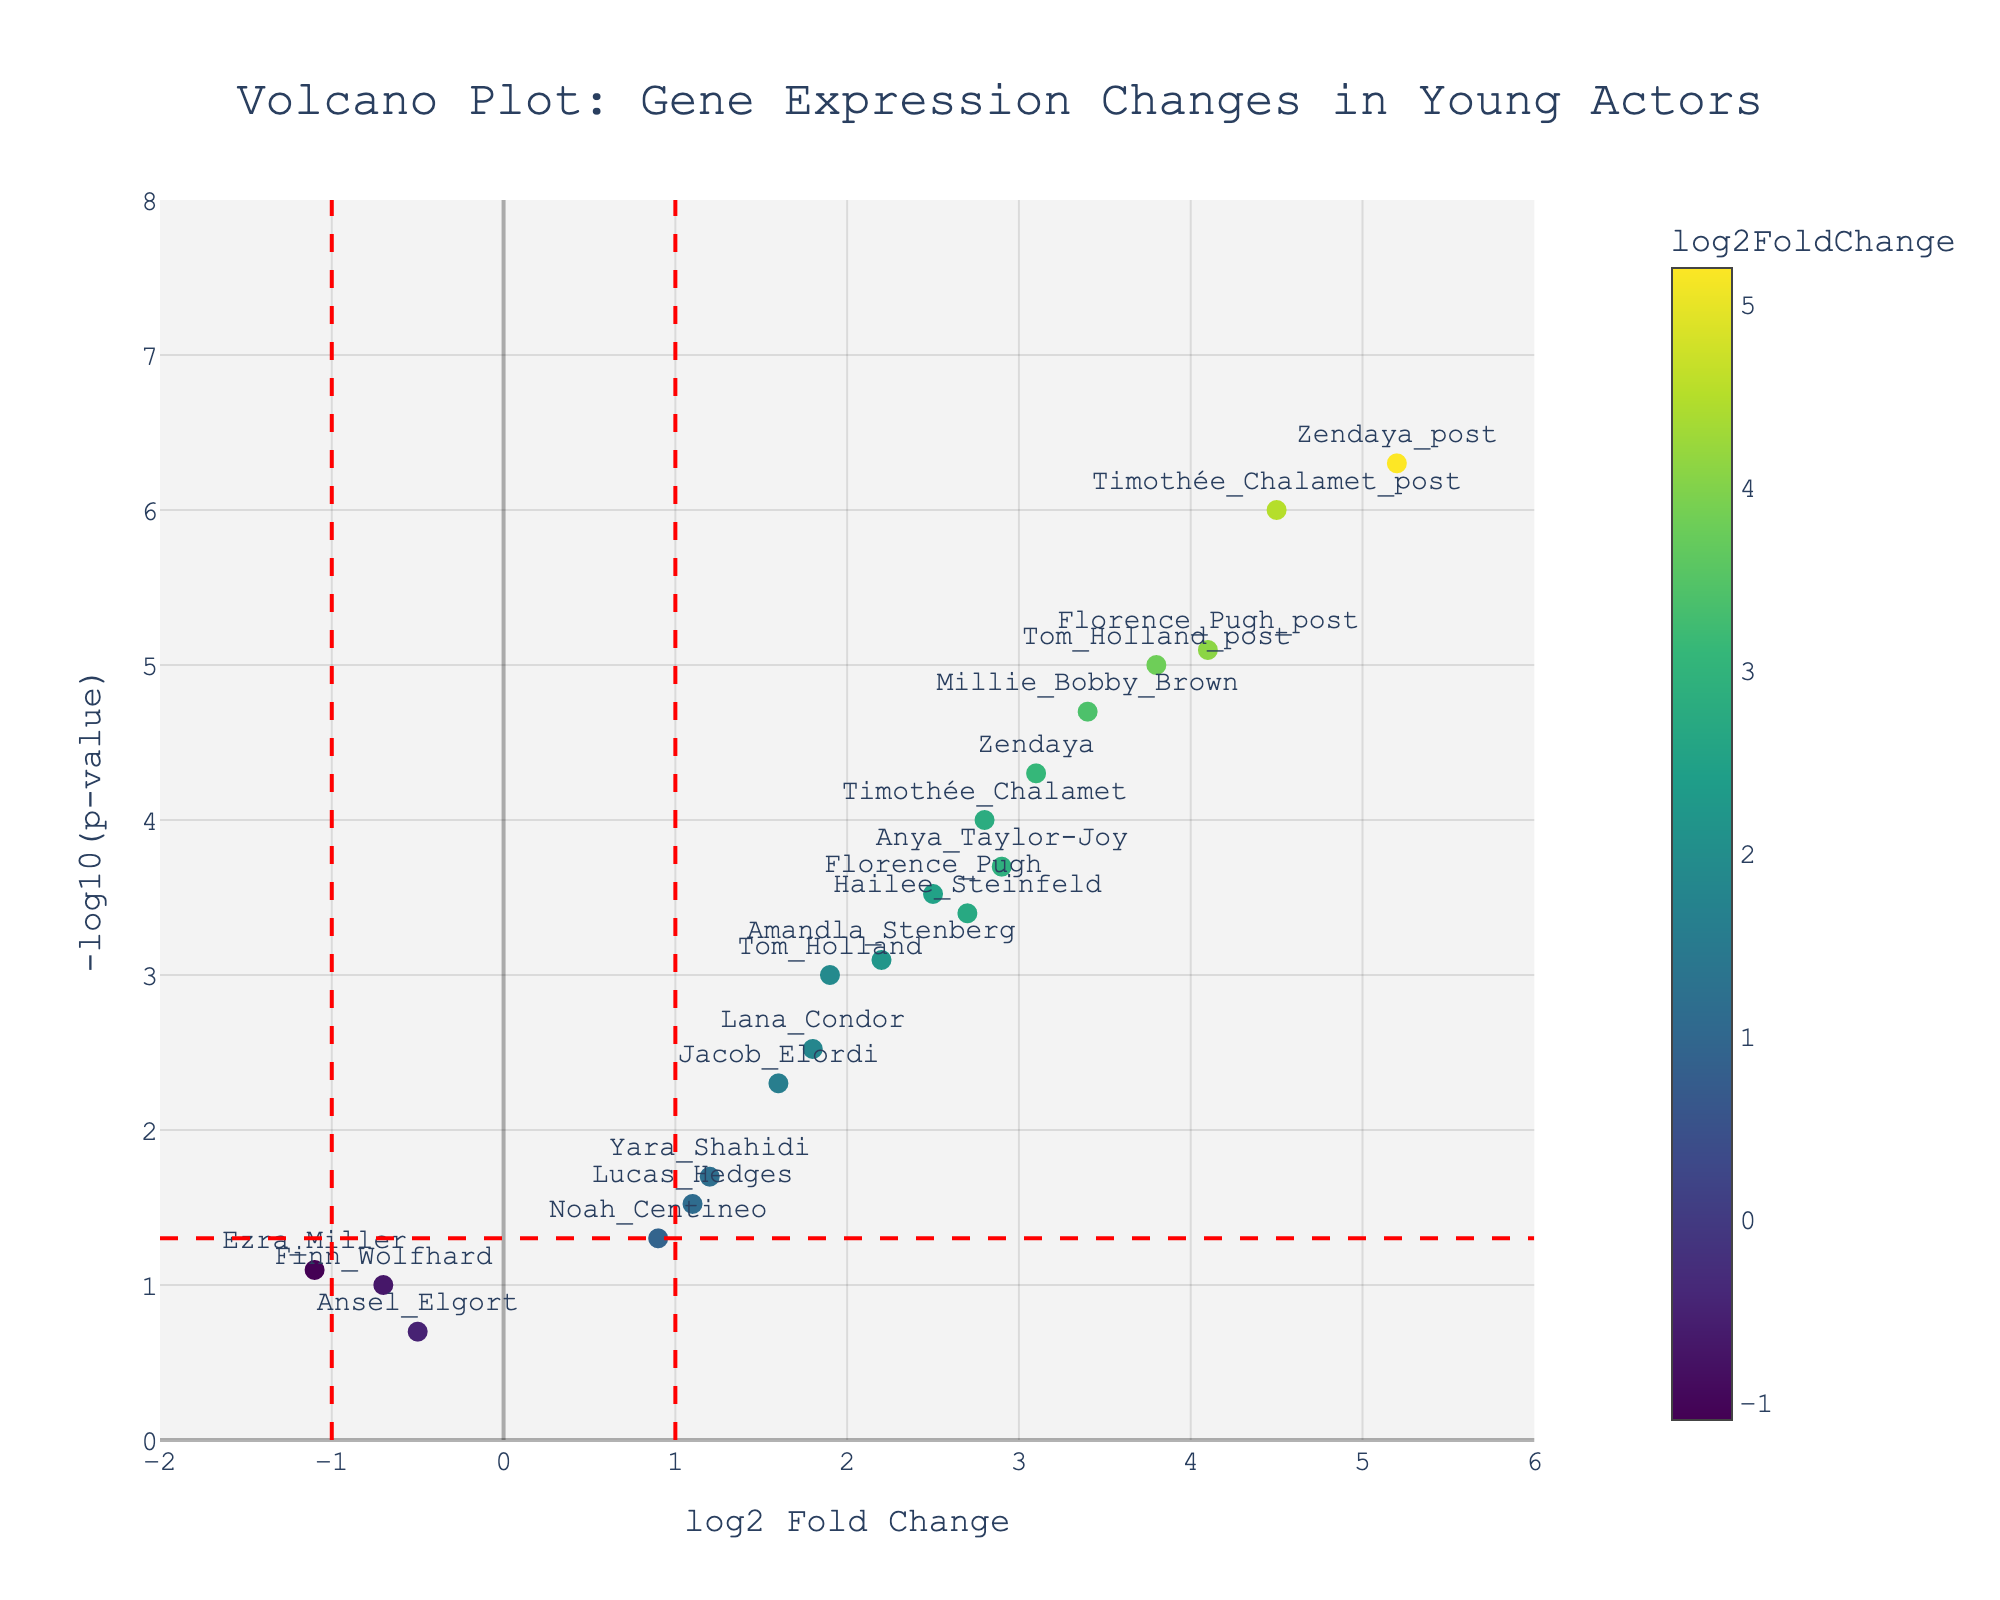What is the title of the figure? The title of the figure is located at the top and is in a large, distinct font for easy readability. It reads "Volcano Plot: Gene Expression Changes in Young Actors".
Answer: Volcano Plot: Gene Expression Changes in Young Actors How many genes show a log2 fold change greater than 2? To determine this, you count the number of data points on the plot with a log2 fold change (x-axis) greater than 2. By visual inspection or referring to the data, we see Timothée Chalamet, Zendaya, Florence Pugh, Millie Bobby Brown, Anya Taylor-Joy, Amandla Stenberg, and Hailee Steinfeld have log2 fold changes greater than 2.
Answer: 7 Which actor has the highest -log10(p-value)? The highest -log10(p-value) corresponds to the highest point on the y-axis. By inspecting the plot, Millie Bobby Brown has the highest point on the y-axis.
Answer: Millie Bobby Brown What is the log2 fold change and p-value for Timothée Chalamet after his breakout role? To find these values, look at the plot where his gene (Timothée Chalamet_post) is labeled and hover over the point. The log2 fold change is 4.5, and the p-value is represented by the y-axis value of -log10(p-value). You can refer to the hover text to confirm which contains the exact values. Timothée Chalamet_post has a log2 fold change of 4.5 and a very small p-value.
Answer: log2 fold change: 4.5, p-value: extremely small (close to zero) Which gene shows the most significant change in expression, and what does this imply? The most significant change can be identified by the highest -log10(p-value) combined with a high log2 fold change. Millie Bobby Brown has both a high log2 fold change and the highest -log10(p-value), making her change in expression the most significant. This implies her breakout role had a considerable impact.
Answer: Millie Bobby Brown; implies significant impact How are p-values represented on the plot, and what does a smaller p-value imply visually? P-values are represented on the y-axis as -log10(p-value). The higher the point on the y-axis, the smaller the p-value. A smaller p-value implies a more statistically significant change in expression.
Answer: Higher on y-axis; more significant change Compare the expression changes of Zendaya and Tom Holland post their breakout roles. To compare their changes, find the points labeled Zendaya_post and Tom Holland_post. Zendaya_post has a log2 fold change of 5.2 with a very small p-value, while Tom Holland_post has a log2 fold change of 3.8 with a very small p-value. Thus, Zendaya has a higher log2 fold change, indicating a more pronounced change.
Answer: Zendaya_post shows more pronounced change than Tom Holland_post What can we infer about actors with log2 fold changes between -1 and 1? Points within the vertical dashed red lines at log2 fold change of -1 and 1 indicate less significant changes in gene expression. These moderate or negligible changes suggest the breakout role may not have drastically influenced them.
Answer: Less significant changes Identify the actors with relatively low significance in gene expression change (high p-value). Actors with low significance will have smaller -log10(p-values) (closer to the x-axis). Finn Wolfhard, Noah Centineo, Ansel Elgort, and Ezra Miller are closer to the x-axis, indicating higher p-values and lower significance.
Answer: Finn Wolfhard, Noah Centineo, Ansel Elgort, Ezra Miller 